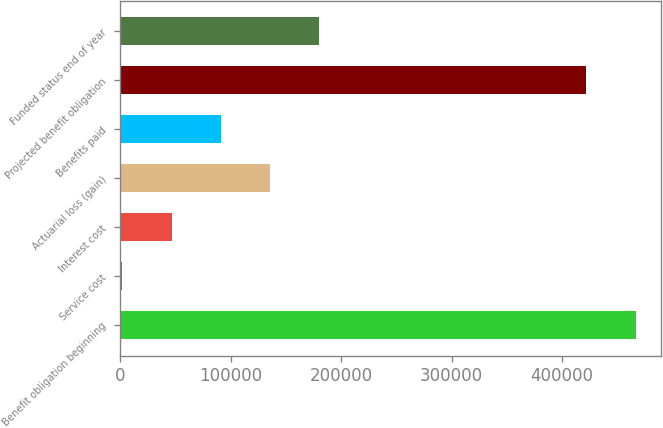Convert chart to OTSL. <chart><loc_0><loc_0><loc_500><loc_500><bar_chart><fcel>Benefit obligation beginning<fcel>Service cost<fcel>Interest cost<fcel>Actuarial loss (gain)<fcel>Benefits paid<fcel>Projected benefit obligation<fcel>Funded status end of year<nl><fcel>466344<fcel>1880<fcel>46488.4<fcel>135705<fcel>91096.8<fcel>421736<fcel>180314<nl></chart> 